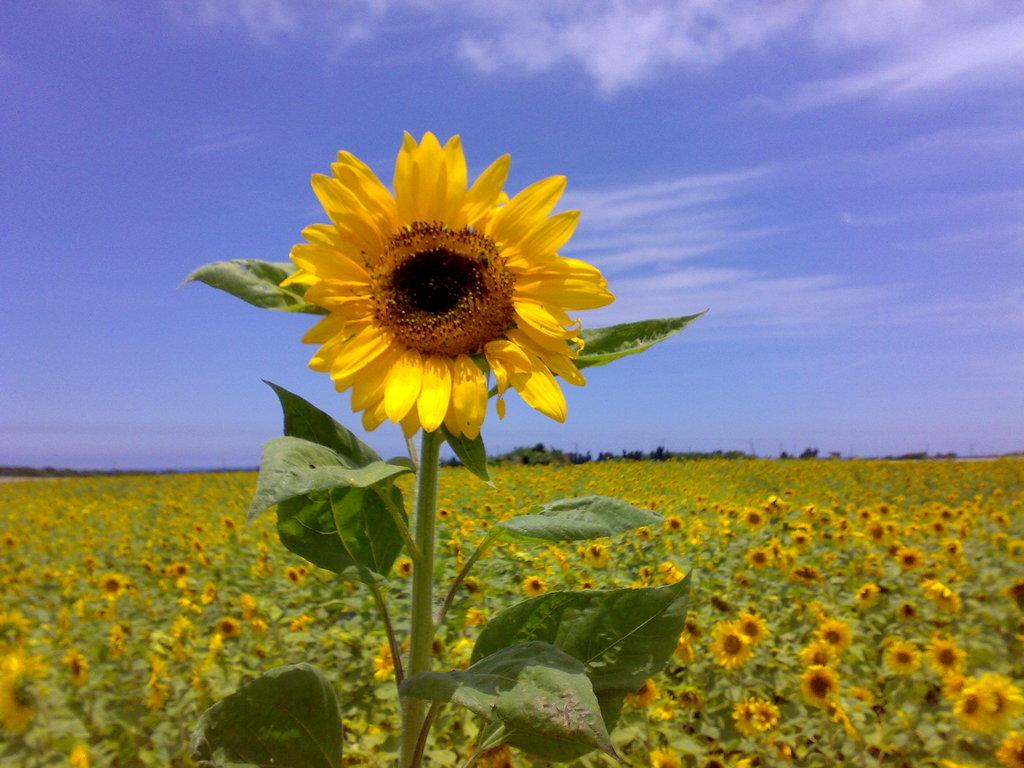What type of plants are in the image? There are sunflower plants in the image. What can be seen in the background of the image? There is sky visible in the background of the image. What educational verse is being recited by the sunflower plants in the image? There is no educational verse being recited by the sunflower plants in the image, as plants do not have the ability to recite verses or engage in educational activities. 